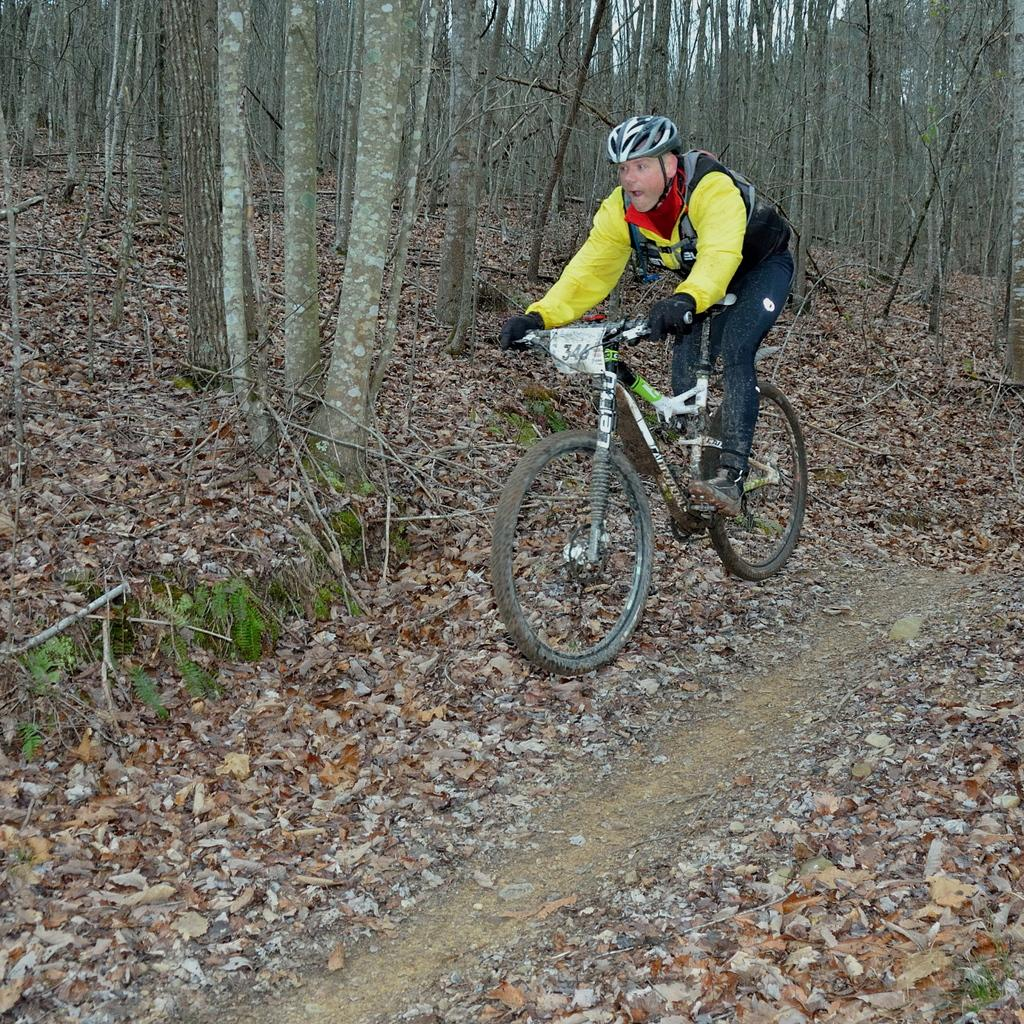What is the man in the image doing? The man is riding a cycle in the image. What is the man holding in the image? There is a paper with numbers in the image, which the man might be holding. What is the surface on which the man is riding the cycle? There is a path with leaves in the image, which the man is riding on. What can be seen in the background of the image? There are trees in the background of the image. What type of rat can be seen running across the path in the image? There is no rat present in the image; it only features a man riding a cycle, a paper with numbers, a path with leaves, and trees in the background. 